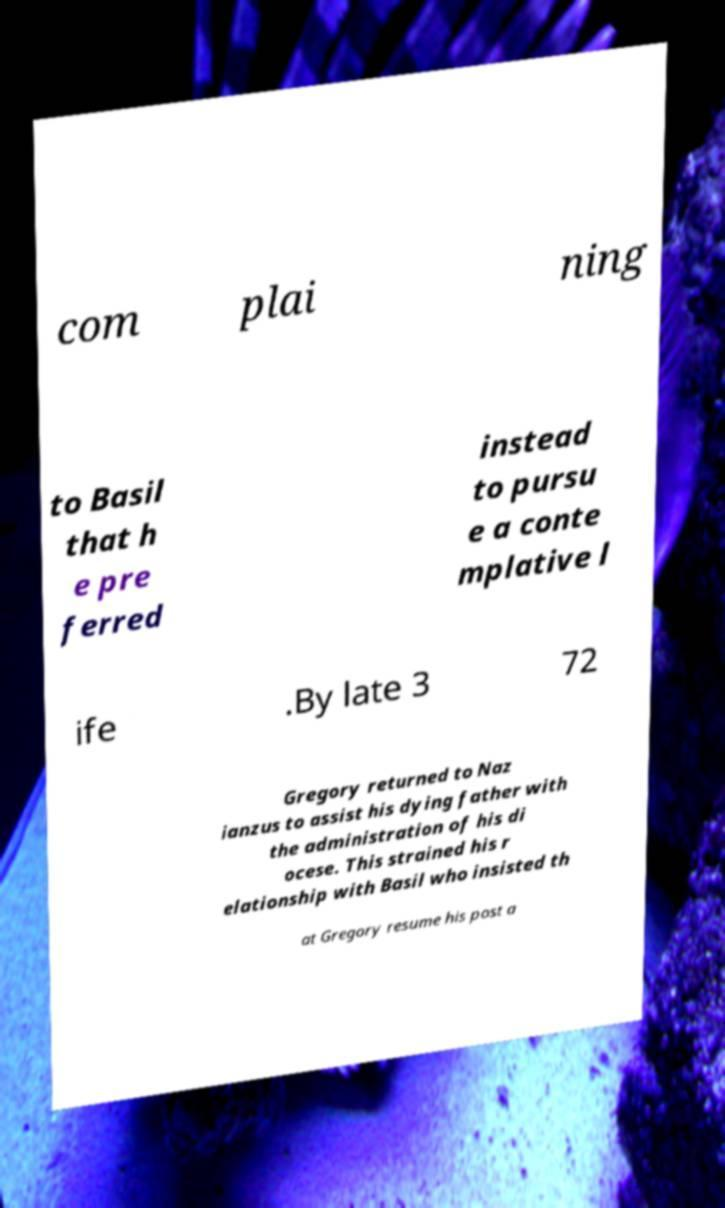Please identify and transcribe the text found in this image. com plai ning to Basil that h e pre ferred instead to pursu e a conte mplative l ife .By late 3 72 Gregory returned to Naz ianzus to assist his dying father with the administration of his di ocese. This strained his r elationship with Basil who insisted th at Gregory resume his post a 